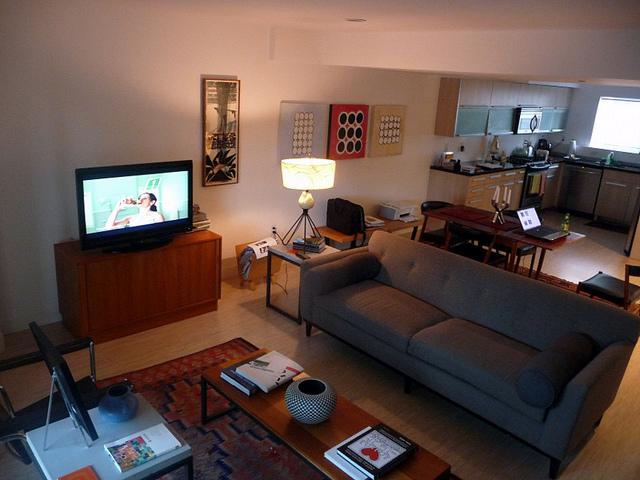What electronics are in the room?
Answer briefly. Tv. How many people are in this photo?
Quick response, please. 0. Are there items and colors here, that suggest a Southwestern motif?
Give a very brief answer. Yes. 